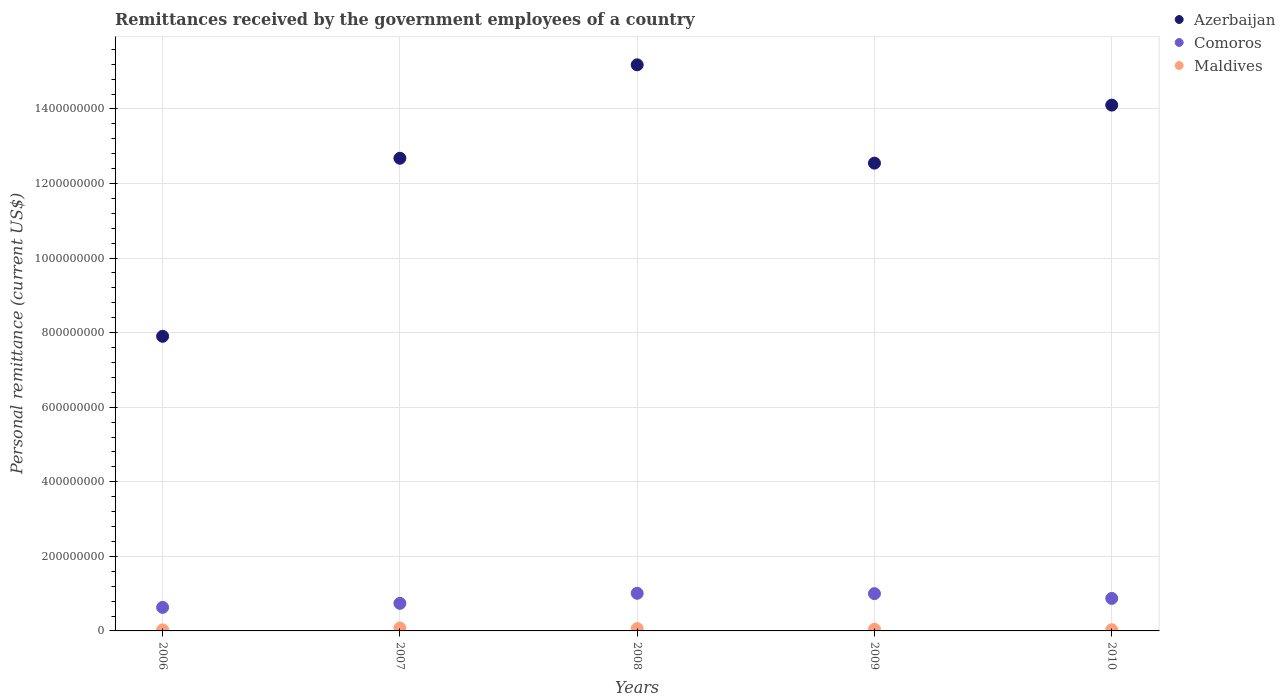How many different coloured dotlines are there?
Keep it short and to the point. 3. Is the number of dotlines equal to the number of legend labels?
Your answer should be very brief. Yes. What is the remittances received by the government employees in Maldives in 2010?
Your answer should be very brief. 3.16e+06. Across all years, what is the maximum remittances received by the government employees in Azerbaijan?
Provide a short and direct response. 1.52e+09. Across all years, what is the minimum remittances received by the government employees in Comoros?
Give a very brief answer. 6.31e+07. In which year was the remittances received by the government employees in Azerbaijan maximum?
Give a very brief answer. 2008. In which year was the remittances received by the government employees in Comoros minimum?
Give a very brief answer. 2006. What is the total remittances received by the government employees in Comoros in the graph?
Provide a short and direct response. 4.25e+08. What is the difference between the remittances received by the government employees in Azerbaijan in 2007 and that in 2009?
Ensure brevity in your answer.  1.31e+07. What is the difference between the remittances received by the government employees in Comoros in 2006 and the remittances received by the government employees in Azerbaijan in 2007?
Make the answer very short. -1.20e+09. What is the average remittances received by the government employees in Comoros per year?
Give a very brief answer. 8.50e+07. In the year 2007, what is the difference between the remittances received by the government employees in Azerbaijan and remittances received by the government employees in Comoros?
Your response must be concise. 1.19e+09. In how many years, is the remittances received by the government employees in Comoros greater than 200000000 US$?
Your answer should be compact. 0. What is the ratio of the remittances received by the government employees in Comoros in 2006 to that in 2010?
Offer a very short reply. 0.72. What is the difference between the highest and the second highest remittances received by the government employees in Azerbaijan?
Offer a terse response. 1.08e+08. What is the difference between the highest and the lowest remittances received by the government employees in Comoros?
Give a very brief answer. 3.78e+07. In how many years, is the remittances received by the government employees in Maldives greater than the average remittances received by the government employees in Maldives taken over all years?
Offer a very short reply. 2. Is it the case that in every year, the sum of the remittances received by the government employees in Comoros and remittances received by the government employees in Maldives  is greater than the remittances received by the government employees in Azerbaijan?
Provide a succinct answer. No. Does the remittances received by the government employees in Azerbaijan monotonically increase over the years?
Your answer should be compact. No. Is the remittances received by the government employees in Maldives strictly greater than the remittances received by the government employees in Comoros over the years?
Provide a succinct answer. No. How many years are there in the graph?
Provide a succinct answer. 5. Does the graph contain any zero values?
Your answer should be very brief. No. Does the graph contain grids?
Give a very brief answer. Yes. How many legend labels are there?
Your answer should be very brief. 3. How are the legend labels stacked?
Offer a terse response. Vertical. What is the title of the graph?
Provide a succinct answer. Remittances received by the government employees of a country. Does "High income" appear as one of the legend labels in the graph?
Ensure brevity in your answer.  No. What is the label or title of the Y-axis?
Keep it short and to the point. Personal remittance (current US$). What is the Personal remittance (current US$) of Azerbaijan in 2006?
Provide a short and direct response. 7.90e+08. What is the Personal remittance (current US$) of Comoros in 2006?
Keep it short and to the point. 6.31e+07. What is the Personal remittance (current US$) of Maldives in 2006?
Offer a terse response. 2.80e+06. What is the Personal remittance (current US$) in Azerbaijan in 2007?
Your answer should be very brief. 1.27e+09. What is the Personal remittance (current US$) in Comoros in 2007?
Provide a succinct answer. 7.39e+07. What is the Personal remittance (current US$) of Maldives in 2007?
Ensure brevity in your answer.  7.93e+06. What is the Personal remittance (current US$) in Azerbaijan in 2008?
Your answer should be compact. 1.52e+09. What is the Personal remittance (current US$) in Comoros in 2008?
Provide a succinct answer. 1.01e+08. What is the Personal remittance (current US$) of Maldives in 2008?
Give a very brief answer. 6.27e+06. What is the Personal remittance (current US$) in Azerbaijan in 2009?
Provide a short and direct response. 1.25e+09. What is the Personal remittance (current US$) of Comoros in 2009?
Keep it short and to the point. 1.00e+08. What is the Personal remittance (current US$) in Maldives in 2009?
Your response must be concise. 4.51e+06. What is the Personal remittance (current US$) of Azerbaijan in 2010?
Your answer should be compact. 1.41e+09. What is the Personal remittance (current US$) in Comoros in 2010?
Ensure brevity in your answer.  8.72e+07. What is the Personal remittance (current US$) of Maldives in 2010?
Offer a terse response. 3.16e+06. Across all years, what is the maximum Personal remittance (current US$) in Azerbaijan?
Provide a succinct answer. 1.52e+09. Across all years, what is the maximum Personal remittance (current US$) of Comoros?
Give a very brief answer. 1.01e+08. Across all years, what is the maximum Personal remittance (current US$) in Maldives?
Keep it short and to the point. 7.93e+06. Across all years, what is the minimum Personal remittance (current US$) of Azerbaijan?
Offer a terse response. 7.90e+08. Across all years, what is the minimum Personal remittance (current US$) in Comoros?
Offer a very short reply. 6.31e+07. Across all years, what is the minimum Personal remittance (current US$) of Maldives?
Your response must be concise. 2.80e+06. What is the total Personal remittance (current US$) of Azerbaijan in the graph?
Ensure brevity in your answer.  6.24e+09. What is the total Personal remittance (current US$) of Comoros in the graph?
Offer a terse response. 4.25e+08. What is the total Personal remittance (current US$) in Maldives in the graph?
Make the answer very short. 2.47e+07. What is the difference between the Personal remittance (current US$) in Azerbaijan in 2006 and that in 2007?
Your answer should be compact. -4.78e+08. What is the difference between the Personal remittance (current US$) of Comoros in 2006 and that in 2007?
Your answer should be compact. -1.08e+07. What is the difference between the Personal remittance (current US$) in Maldives in 2006 and that in 2007?
Give a very brief answer. -5.13e+06. What is the difference between the Personal remittance (current US$) in Azerbaijan in 2006 and that in 2008?
Offer a very short reply. -7.28e+08. What is the difference between the Personal remittance (current US$) in Comoros in 2006 and that in 2008?
Give a very brief answer. -3.78e+07. What is the difference between the Personal remittance (current US$) of Maldives in 2006 and that in 2008?
Give a very brief answer. -3.47e+06. What is the difference between the Personal remittance (current US$) of Azerbaijan in 2006 and that in 2009?
Offer a very short reply. -4.64e+08. What is the difference between the Personal remittance (current US$) of Comoros in 2006 and that in 2009?
Your answer should be very brief. -3.69e+07. What is the difference between the Personal remittance (current US$) in Maldives in 2006 and that in 2009?
Make the answer very short. -1.71e+06. What is the difference between the Personal remittance (current US$) of Azerbaijan in 2006 and that in 2010?
Ensure brevity in your answer.  -6.20e+08. What is the difference between the Personal remittance (current US$) of Comoros in 2006 and that in 2010?
Give a very brief answer. -2.40e+07. What is the difference between the Personal remittance (current US$) of Maldives in 2006 and that in 2010?
Ensure brevity in your answer.  -3.59e+05. What is the difference between the Personal remittance (current US$) in Azerbaijan in 2007 and that in 2008?
Ensure brevity in your answer.  -2.51e+08. What is the difference between the Personal remittance (current US$) of Comoros in 2007 and that in 2008?
Keep it short and to the point. -2.70e+07. What is the difference between the Personal remittance (current US$) in Maldives in 2007 and that in 2008?
Keep it short and to the point. 1.67e+06. What is the difference between the Personal remittance (current US$) of Azerbaijan in 2007 and that in 2009?
Your response must be concise. 1.31e+07. What is the difference between the Personal remittance (current US$) in Comoros in 2007 and that in 2009?
Make the answer very short. -2.61e+07. What is the difference between the Personal remittance (current US$) of Maldives in 2007 and that in 2009?
Your answer should be compact. 3.42e+06. What is the difference between the Personal remittance (current US$) of Azerbaijan in 2007 and that in 2010?
Provide a short and direct response. -1.43e+08. What is the difference between the Personal remittance (current US$) in Comoros in 2007 and that in 2010?
Your answer should be compact. -1.32e+07. What is the difference between the Personal remittance (current US$) of Maldives in 2007 and that in 2010?
Your response must be concise. 4.77e+06. What is the difference between the Personal remittance (current US$) in Azerbaijan in 2008 and that in 2009?
Provide a succinct answer. 2.64e+08. What is the difference between the Personal remittance (current US$) of Comoros in 2008 and that in 2009?
Your answer should be compact. 9.12e+05. What is the difference between the Personal remittance (current US$) in Maldives in 2008 and that in 2009?
Provide a short and direct response. 1.75e+06. What is the difference between the Personal remittance (current US$) of Azerbaijan in 2008 and that in 2010?
Your answer should be very brief. 1.08e+08. What is the difference between the Personal remittance (current US$) in Comoros in 2008 and that in 2010?
Your response must be concise. 1.37e+07. What is the difference between the Personal remittance (current US$) in Maldives in 2008 and that in 2010?
Provide a short and direct response. 3.11e+06. What is the difference between the Personal remittance (current US$) in Azerbaijan in 2009 and that in 2010?
Provide a succinct answer. -1.56e+08. What is the difference between the Personal remittance (current US$) of Comoros in 2009 and that in 2010?
Offer a very short reply. 1.28e+07. What is the difference between the Personal remittance (current US$) in Maldives in 2009 and that in 2010?
Ensure brevity in your answer.  1.35e+06. What is the difference between the Personal remittance (current US$) in Azerbaijan in 2006 and the Personal remittance (current US$) in Comoros in 2007?
Ensure brevity in your answer.  7.16e+08. What is the difference between the Personal remittance (current US$) of Azerbaijan in 2006 and the Personal remittance (current US$) of Maldives in 2007?
Provide a succinct answer. 7.82e+08. What is the difference between the Personal remittance (current US$) in Comoros in 2006 and the Personal remittance (current US$) in Maldives in 2007?
Provide a succinct answer. 5.52e+07. What is the difference between the Personal remittance (current US$) of Azerbaijan in 2006 and the Personal remittance (current US$) of Comoros in 2008?
Give a very brief answer. 6.89e+08. What is the difference between the Personal remittance (current US$) of Azerbaijan in 2006 and the Personal remittance (current US$) of Maldives in 2008?
Provide a short and direct response. 7.84e+08. What is the difference between the Personal remittance (current US$) of Comoros in 2006 and the Personal remittance (current US$) of Maldives in 2008?
Keep it short and to the point. 5.69e+07. What is the difference between the Personal remittance (current US$) of Azerbaijan in 2006 and the Personal remittance (current US$) of Comoros in 2009?
Provide a succinct answer. 6.90e+08. What is the difference between the Personal remittance (current US$) of Azerbaijan in 2006 and the Personal remittance (current US$) of Maldives in 2009?
Your answer should be compact. 7.86e+08. What is the difference between the Personal remittance (current US$) in Comoros in 2006 and the Personal remittance (current US$) in Maldives in 2009?
Ensure brevity in your answer.  5.86e+07. What is the difference between the Personal remittance (current US$) of Azerbaijan in 2006 and the Personal remittance (current US$) of Comoros in 2010?
Provide a succinct answer. 7.03e+08. What is the difference between the Personal remittance (current US$) in Azerbaijan in 2006 and the Personal remittance (current US$) in Maldives in 2010?
Make the answer very short. 7.87e+08. What is the difference between the Personal remittance (current US$) in Comoros in 2006 and the Personal remittance (current US$) in Maldives in 2010?
Offer a very short reply. 6.00e+07. What is the difference between the Personal remittance (current US$) in Azerbaijan in 2007 and the Personal remittance (current US$) in Comoros in 2008?
Ensure brevity in your answer.  1.17e+09. What is the difference between the Personal remittance (current US$) of Azerbaijan in 2007 and the Personal remittance (current US$) of Maldives in 2008?
Offer a terse response. 1.26e+09. What is the difference between the Personal remittance (current US$) of Comoros in 2007 and the Personal remittance (current US$) of Maldives in 2008?
Offer a terse response. 6.77e+07. What is the difference between the Personal remittance (current US$) of Azerbaijan in 2007 and the Personal remittance (current US$) of Comoros in 2009?
Your answer should be compact. 1.17e+09. What is the difference between the Personal remittance (current US$) in Azerbaijan in 2007 and the Personal remittance (current US$) in Maldives in 2009?
Offer a terse response. 1.26e+09. What is the difference between the Personal remittance (current US$) in Comoros in 2007 and the Personal remittance (current US$) in Maldives in 2009?
Provide a succinct answer. 6.94e+07. What is the difference between the Personal remittance (current US$) in Azerbaijan in 2007 and the Personal remittance (current US$) in Comoros in 2010?
Ensure brevity in your answer.  1.18e+09. What is the difference between the Personal remittance (current US$) in Azerbaijan in 2007 and the Personal remittance (current US$) in Maldives in 2010?
Provide a succinct answer. 1.26e+09. What is the difference between the Personal remittance (current US$) of Comoros in 2007 and the Personal remittance (current US$) of Maldives in 2010?
Your response must be concise. 7.08e+07. What is the difference between the Personal remittance (current US$) of Azerbaijan in 2008 and the Personal remittance (current US$) of Comoros in 2009?
Ensure brevity in your answer.  1.42e+09. What is the difference between the Personal remittance (current US$) of Azerbaijan in 2008 and the Personal remittance (current US$) of Maldives in 2009?
Your answer should be compact. 1.51e+09. What is the difference between the Personal remittance (current US$) of Comoros in 2008 and the Personal remittance (current US$) of Maldives in 2009?
Ensure brevity in your answer.  9.64e+07. What is the difference between the Personal remittance (current US$) in Azerbaijan in 2008 and the Personal remittance (current US$) in Comoros in 2010?
Provide a succinct answer. 1.43e+09. What is the difference between the Personal remittance (current US$) of Azerbaijan in 2008 and the Personal remittance (current US$) of Maldives in 2010?
Offer a very short reply. 1.52e+09. What is the difference between the Personal remittance (current US$) in Comoros in 2008 and the Personal remittance (current US$) in Maldives in 2010?
Your response must be concise. 9.78e+07. What is the difference between the Personal remittance (current US$) in Azerbaijan in 2009 and the Personal remittance (current US$) in Comoros in 2010?
Offer a very short reply. 1.17e+09. What is the difference between the Personal remittance (current US$) in Azerbaijan in 2009 and the Personal remittance (current US$) in Maldives in 2010?
Make the answer very short. 1.25e+09. What is the difference between the Personal remittance (current US$) in Comoros in 2009 and the Personal remittance (current US$) in Maldives in 2010?
Offer a terse response. 9.68e+07. What is the average Personal remittance (current US$) of Azerbaijan per year?
Give a very brief answer. 1.25e+09. What is the average Personal remittance (current US$) of Comoros per year?
Your answer should be compact. 8.50e+07. What is the average Personal remittance (current US$) in Maldives per year?
Ensure brevity in your answer.  4.93e+06. In the year 2006, what is the difference between the Personal remittance (current US$) in Azerbaijan and Personal remittance (current US$) in Comoros?
Your response must be concise. 7.27e+08. In the year 2006, what is the difference between the Personal remittance (current US$) of Azerbaijan and Personal remittance (current US$) of Maldives?
Make the answer very short. 7.87e+08. In the year 2006, what is the difference between the Personal remittance (current US$) of Comoros and Personal remittance (current US$) of Maldives?
Give a very brief answer. 6.03e+07. In the year 2007, what is the difference between the Personal remittance (current US$) of Azerbaijan and Personal remittance (current US$) of Comoros?
Your answer should be compact. 1.19e+09. In the year 2007, what is the difference between the Personal remittance (current US$) in Azerbaijan and Personal remittance (current US$) in Maldives?
Offer a very short reply. 1.26e+09. In the year 2007, what is the difference between the Personal remittance (current US$) in Comoros and Personal remittance (current US$) in Maldives?
Your answer should be very brief. 6.60e+07. In the year 2008, what is the difference between the Personal remittance (current US$) of Azerbaijan and Personal remittance (current US$) of Comoros?
Give a very brief answer. 1.42e+09. In the year 2008, what is the difference between the Personal remittance (current US$) in Azerbaijan and Personal remittance (current US$) in Maldives?
Your response must be concise. 1.51e+09. In the year 2008, what is the difference between the Personal remittance (current US$) in Comoros and Personal remittance (current US$) in Maldives?
Ensure brevity in your answer.  9.47e+07. In the year 2009, what is the difference between the Personal remittance (current US$) in Azerbaijan and Personal remittance (current US$) in Comoros?
Offer a terse response. 1.15e+09. In the year 2009, what is the difference between the Personal remittance (current US$) in Azerbaijan and Personal remittance (current US$) in Maldives?
Offer a terse response. 1.25e+09. In the year 2009, what is the difference between the Personal remittance (current US$) of Comoros and Personal remittance (current US$) of Maldives?
Offer a very short reply. 9.55e+07. In the year 2010, what is the difference between the Personal remittance (current US$) in Azerbaijan and Personal remittance (current US$) in Comoros?
Offer a very short reply. 1.32e+09. In the year 2010, what is the difference between the Personal remittance (current US$) of Azerbaijan and Personal remittance (current US$) of Maldives?
Offer a terse response. 1.41e+09. In the year 2010, what is the difference between the Personal remittance (current US$) in Comoros and Personal remittance (current US$) in Maldives?
Provide a short and direct response. 8.40e+07. What is the ratio of the Personal remittance (current US$) in Azerbaijan in 2006 to that in 2007?
Ensure brevity in your answer.  0.62. What is the ratio of the Personal remittance (current US$) in Comoros in 2006 to that in 2007?
Your response must be concise. 0.85. What is the ratio of the Personal remittance (current US$) of Maldives in 2006 to that in 2007?
Ensure brevity in your answer.  0.35. What is the ratio of the Personal remittance (current US$) of Azerbaijan in 2006 to that in 2008?
Offer a terse response. 0.52. What is the ratio of the Personal remittance (current US$) in Comoros in 2006 to that in 2008?
Ensure brevity in your answer.  0.63. What is the ratio of the Personal remittance (current US$) of Maldives in 2006 to that in 2008?
Provide a short and direct response. 0.45. What is the ratio of the Personal remittance (current US$) of Azerbaijan in 2006 to that in 2009?
Your response must be concise. 0.63. What is the ratio of the Personal remittance (current US$) in Comoros in 2006 to that in 2009?
Keep it short and to the point. 0.63. What is the ratio of the Personal remittance (current US$) in Maldives in 2006 to that in 2009?
Give a very brief answer. 0.62. What is the ratio of the Personal remittance (current US$) of Azerbaijan in 2006 to that in 2010?
Your response must be concise. 0.56. What is the ratio of the Personal remittance (current US$) of Comoros in 2006 to that in 2010?
Offer a very short reply. 0.72. What is the ratio of the Personal remittance (current US$) of Maldives in 2006 to that in 2010?
Make the answer very short. 0.89. What is the ratio of the Personal remittance (current US$) of Azerbaijan in 2007 to that in 2008?
Ensure brevity in your answer.  0.83. What is the ratio of the Personal remittance (current US$) of Comoros in 2007 to that in 2008?
Your response must be concise. 0.73. What is the ratio of the Personal remittance (current US$) of Maldives in 2007 to that in 2008?
Offer a very short reply. 1.27. What is the ratio of the Personal remittance (current US$) of Azerbaijan in 2007 to that in 2009?
Your answer should be compact. 1.01. What is the ratio of the Personal remittance (current US$) in Comoros in 2007 to that in 2009?
Offer a very short reply. 0.74. What is the ratio of the Personal remittance (current US$) of Maldives in 2007 to that in 2009?
Offer a terse response. 1.76. What is the ratio of the Personal remittance (current US$) of Azerbaijan in 2007 to that in 2010?
Provide a short and direct response. 0.9. What is the ratio of the Personal remittance (current US$) of Comoros in 2007 to that in 2010?
Make the answer very short. 0.85. What is the ratio of the Personal remittance (current US$) in Maldives in 2007 to that in 2010?
Your response must be concise. 2.51. What is the ratio of the Personal remittance (current US$) in Azerbaijan in 2008 to that in 2009?
Offer a very short reply. 1.21. What is the ratio of the Personal remittance (current US$) in Comoros in 2008 to that in 2009?
Make the answer very short. 1.01. What is the ratio of the Personal remittance (current US$) of Maldives in 2008 to that in 2009?
Your answer should be very brief. 1.39. What is the ratio of the Personal remittance (current US$) in Azerbaijan in 2008 to that in 2010?
Give a very brief answer. 1.08. What is the ratio of the Personal remittance (current US$) in Comoros in 2008 to that in 2010?
Your response must be concise. 1.16. What is the ratio of the Personal remittance (current US$) in Maldives in 2008 to that in 2010?
Offer a terse response. 1.98. What is the ratio of the Personal remittance (current US$) in Azerbaijan in 2009 to that in 2010?
Provide a short and direct response. 0.89. What is the ratio of the Personal remittance (current US$) of Comoros in 2009 to that in 2010?
Offer a terse response. 1.15. What is the ratio of the Personal remittance (current US$) in Maldives in 2009 to that in 2010?
Keep it short and to the point. 1.43. What is the difference between the highest and the second highest Personal remittance (current US$) in Azerbaijan?
Offer a very short reply. 1.08e+08. What is the difference between the highest and the second highest Personal remittance (current US$) in Comoros?
Make the answer very short. 9.12e+05. What is the difference between the highest and the second highest Personal remittance (current US$) in Maldives?
Keep it short and to the point. 1.67e+06. What is the difference between the highest and the lowest Personal remittance (current US$) of Azerbaijan?
Offer a very short reply. 7.28e+08. What is the difference between the highest and the lowest Personal remittance (current US$) of Comoros?
Keep it short and to the point. 3.78e+07. What is the difference between the highest and the lowest Personal remittance (current US$) in Maldives?
Provide a short and direct response. 5.13e+06. 